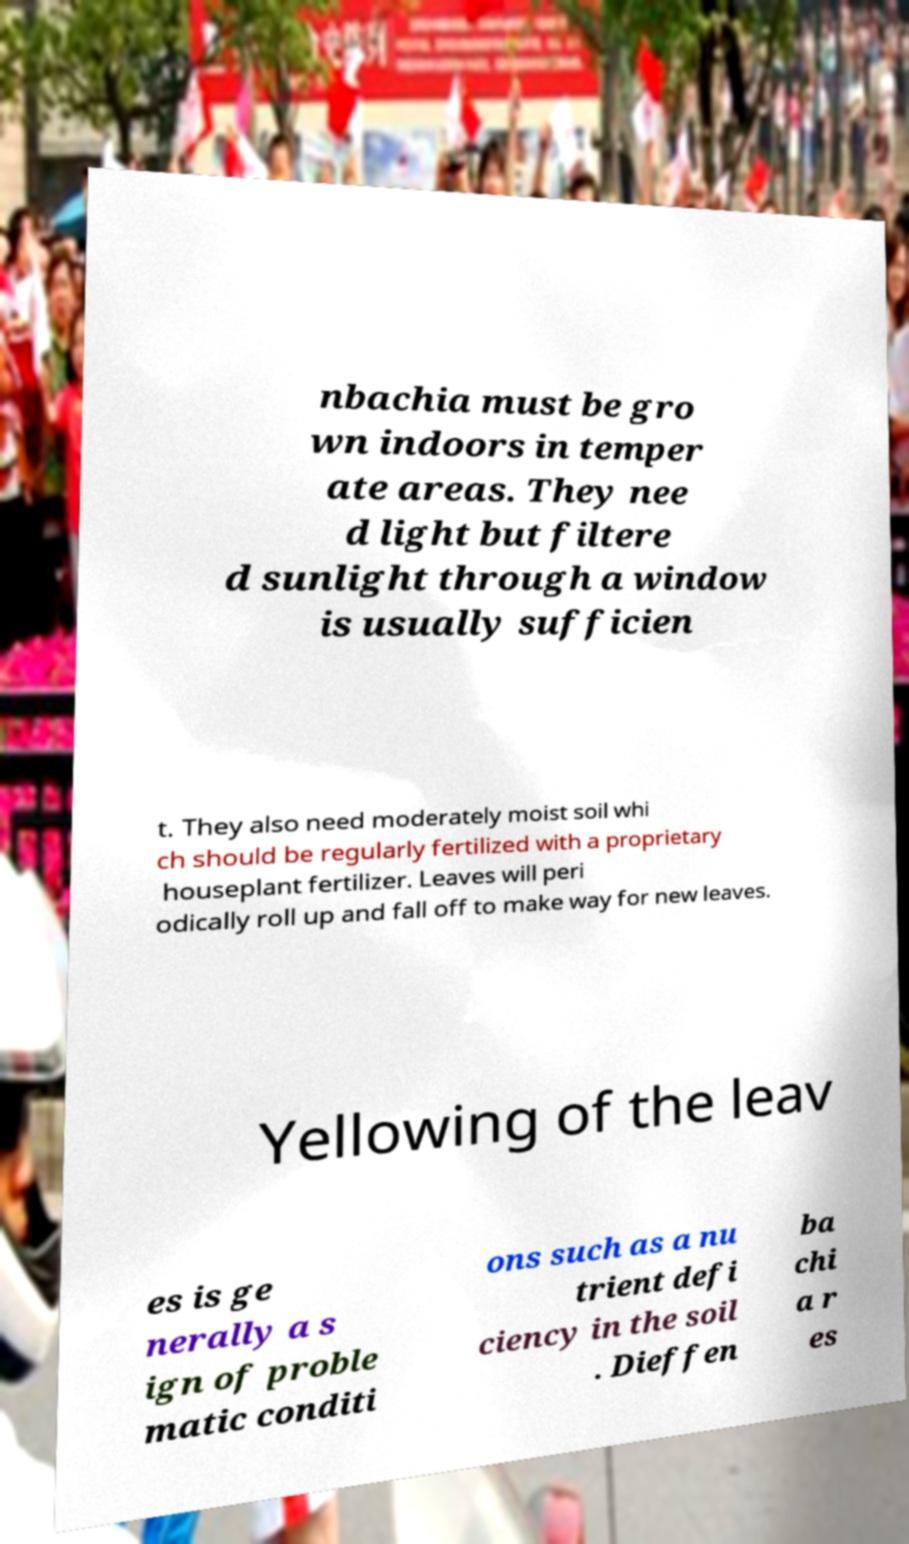Please identify and transcribe the text found in this image. nbachia must be gro wn indoors in temper ate areas. They nee d light but filtere d sunlight through a window is usually sufficien t. They also need moderately moist soil whi ch should be regularly fertilized with a proprietary houseplant fertilizer. Leaves will peri odically roll up and fall off to make way for new leaves. Yellowing of the leav es is ge nerally a s ign of proble matic conditi ons such as a nu trient defi ciency in the soil . Dieffen ba chi a r es 